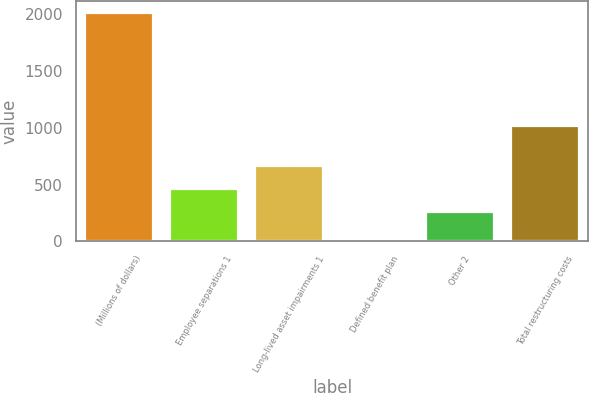Convert chart. <chart><loc_0><loc_0><loc_500><loc_500><bar_chart><fcel>(Millions of dollars)<fcel>Employee separations 1<fcel>Long-lived asset impairments 1<fcel>Defined benefit plan<fcel>Other 2<fcel>Total restructuring costs<nl><fcel>2016<fcel>462.9<fcel>663.8<fcel>7<fcel>262<fcel>1019<nl></chart> 